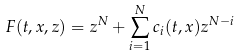<formula> <loc_0><loc_0><loc_500><loc_500>F ( t , x , z ) = z ^ { N } + \sum _ { i = 1 } ^ { N } c _ { i } ( t , x ) z ^ { N - i }</formula> 